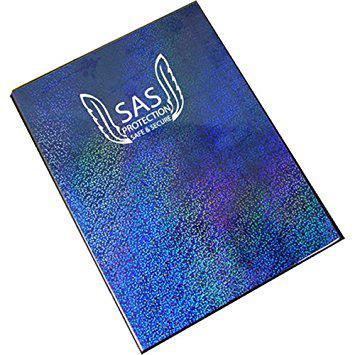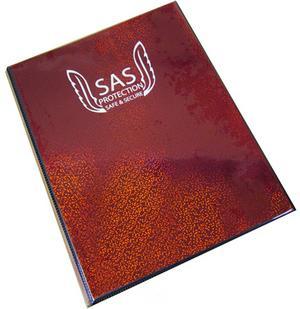The first image is the image on the left, the second image is the image on the right. For the images shown, is this caption "There is one red and one blue folder." true? Answer yes or no. Yes. 